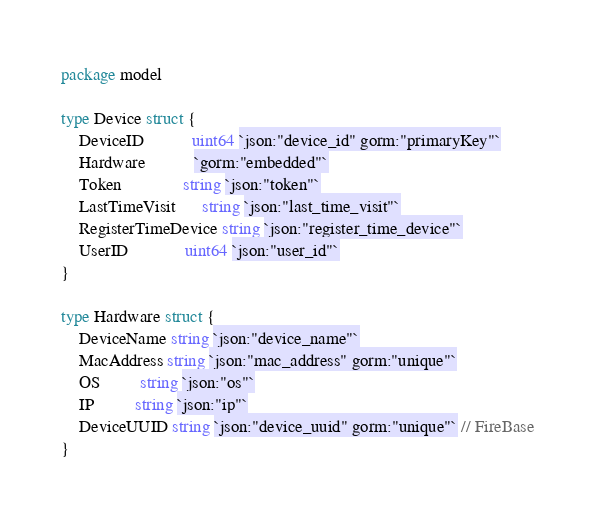<code> <loc_0><loc_0><loc_500><loc_500><_Go_>package model

type Device struct {
	DeviceID           uint64 `json:"device_id" gorm:"primaryKey"`
	Hardware           `gorm:"embedded"`
	Token              string `json:"token"`
	LastTimeVisit      string `json:"last_time_visit"`
	RegisterTimeDevice string `json:"register_time_device"`
	UserID             uint64 `json:"user_id"`
}

type Hardware struct {
	DeviceName string `json:"device_name"`
	MacAddress string `json:"mac_address" gorm:"unique"`
	OS         string `json:"os"`
	IP         string `json:"ip"`
	DeviceUUID string `json:"device_uuid" gorm:"unique"` // FireBase
}
</code> 